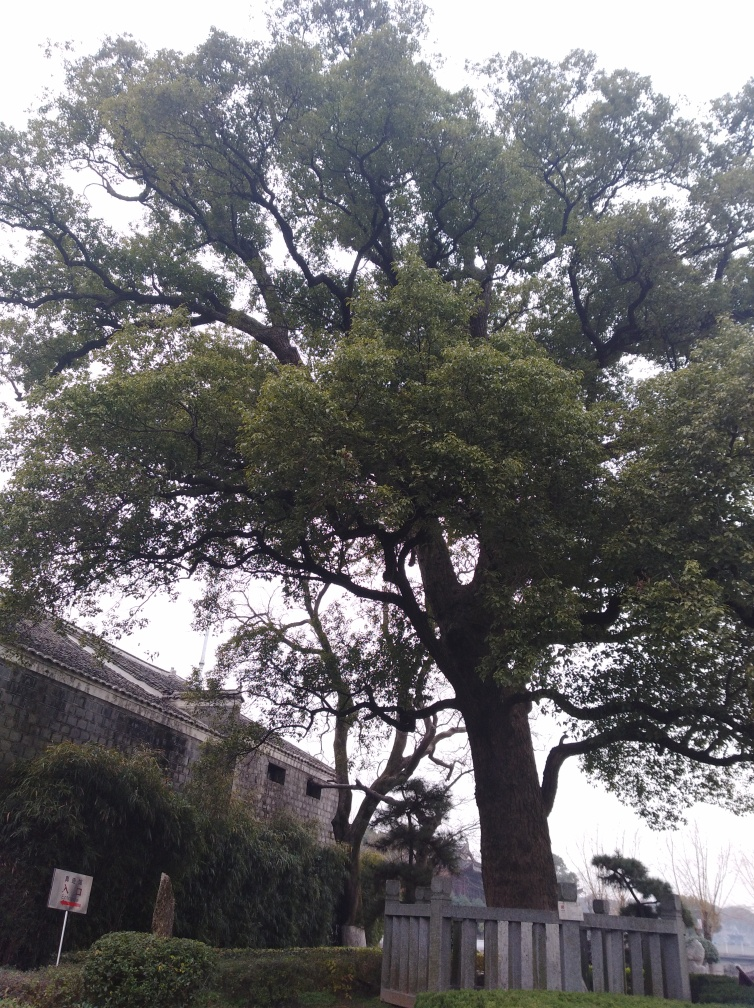How would you describe the sharpness of the image? The sharpness of the image is fairly high, allowing for clear visibility of the individual leaves on the tree and the textures of the stone wall behind it. Although some details might appear a bit softer due to natural lighting conditions and camera focus, overall, it presents a nicely captured scene with discernible details. 